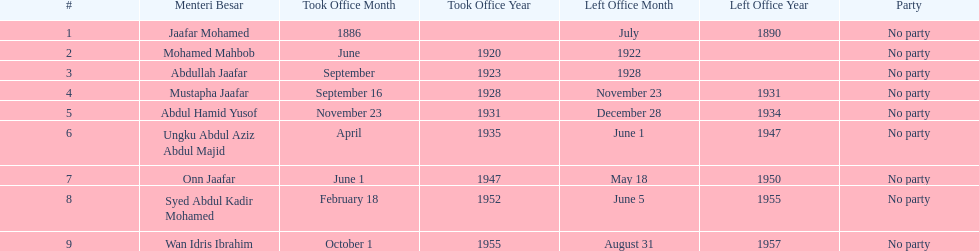Who is listed below onn jaafar? Syed Abdul Kadir Mohamed. 